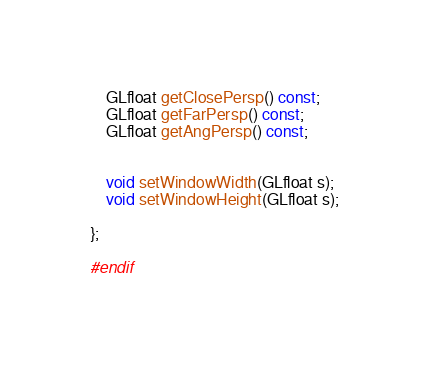Convert code to text. <code><loc_0><loc_0><loc_500><loc_500><_C++_>
    GLfloat getClosePersp() const;
    GLfloat getFarPersp() const;
    GLfloat getAngPersp() const;


    void setWindowWidth(GLfloat s);
    void setWindowHeight(GLfloat s);

};

#endif</code> 